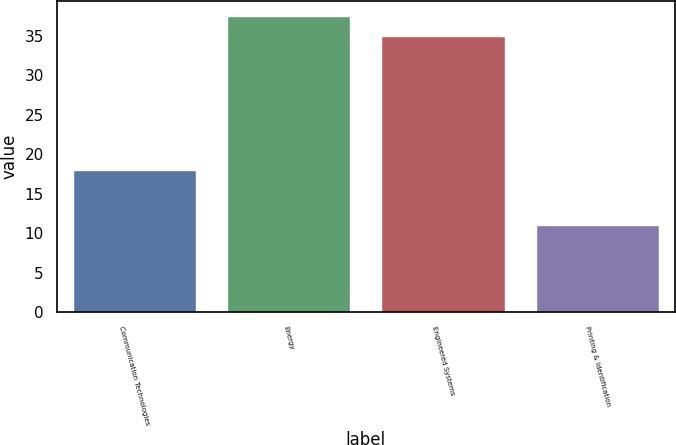Convert chart. <chart><loc_0><loc_0><loc_500><loc_500><bar_chart><fcel>Communication Technologies<fcel>Energy<fcel>Engineered Systems<fcel>Printing & Identification<nl><fcel>18<fcel>37.5<fcel>35<fcel>11<nl></chart> 